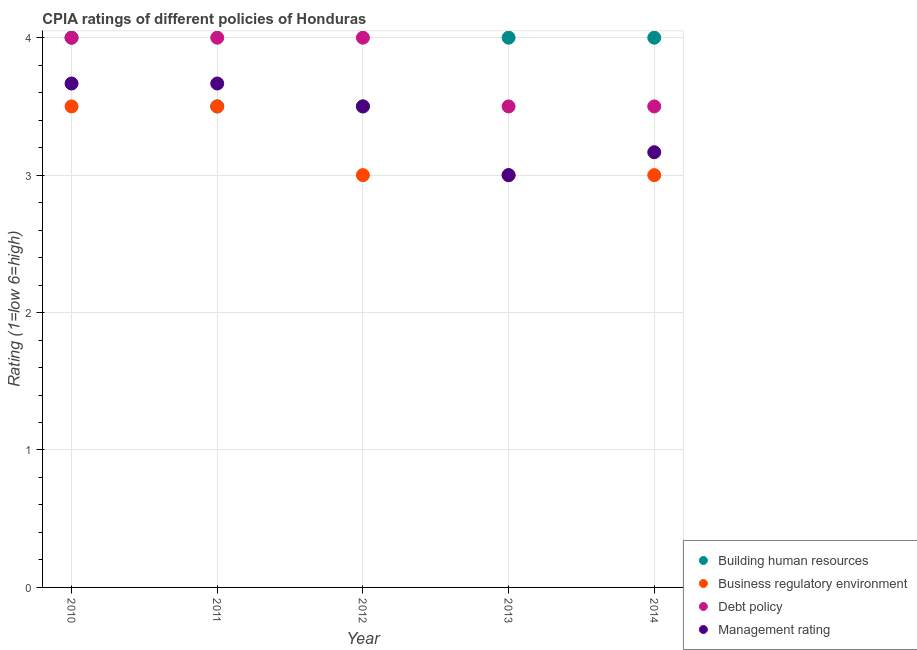Is the number of dotlines equal to the number of legend labels?
Give a very brief answer. Yes. What is the cpia rating of debt policy in 2013?
Your answer should be very brief. 3.5. Across all years, what is the maximum cpia rating of building human resources?
Provide a succinct answer. 4. In which year was the cpia rating of management maximum?
Offer a very short reply. 2010. What is the difference between the cpia rating of management in 2010 and the cpia rating of business regulatory environment in 2014?
Make the answer very short. 0.67. In the year 2011, what is the difference between the cpia rating of management and cpia rating of business regulatory environment?
Your answer should be very brief. 0.17. What is the ratio of the cpia rating of business regulatory environment in 2011 to that in 2012?
Make the answer very short. 1.17. Is the sum of the cpia rating of business regulatory environment in 2011 and 2014 greater than the maximum cpia rating of management across all years?
Give a very brief answer. Yes. Is it the case that in every year, the sum of the cpia rating of debt policy and cpia rating of business regulatory environment is greater than the sum of cpia rating of building human resources and cpia rating of management?
Offer a terse response. No. Is it the case that in every year, the sum of the cpia rating of building human resources and cpia rating of business regulatory environment is greater than the cpia rating of debt policy?
Offer a terse response. Yes. Is the cpia rating of debt policy strictly greater than the cpia rating of building human resources over the years?
Provide a succinct answer. No. Is the cpia rating of business regulatory environment strictly less than the cpia rating of building human resources over the years?
Make the answer very short. No. How many dotlines are there?
Ensure brevity in your answer.  4. How many years are there in the graph?
Make the answer very short. 5. What is the difference between two consecutive major ticks on the Y-axis?
Your answer should be compact. 1. Are the values on the major ticks of Y-axis written in scientific E-notation?
Give a very brief answer. No. Does the graph contain any zero values?
Offer a very short reply. No. Does the graph contain grids?
Your answer should be very brief. Yes. How many legend labels are there?
Make the answer very short. 4. What is the title of the graph?
Your response must be concise. CPIA ratings of different policies of Honduras. Does "Arable land" appear as one of the legend labels in the graph?
Your answer should be very brief. No. What is the label or title of the X-axis?
Your answer should be very brief. Year. What is the label or title of the Y-axis?
Make the answer very short. Rating (1=low 6=high). What is the Rating (1=low 6=high) in Business regulatory environment in 2010?
Your answer should be compact. 3.5. What is the Rating (1=low 6=high) in Management rating in 2010?
Your answer should be compact. 3.67. What is the Rating (1=low 6=high) of Building human resources in 2011?
Offer a terse response. 3.5. What is the Rating (1=low 6=high) of Business regulatory environment in 2011?
Your answer should be compact. 3.5. What is the Rating (1=low 6=high) in Debt policy in 2011?
Your response must be concise. 4. What is the Rating (1=low 6=high) of Management rating in 2011?
Provide a short and direct response. 3.67. What is the Rating (1=low 6=high) of Building human resources in 2012?
Your answer should be compact. 3.5. What is the Rating (1=low 6=high) in Debt policy in 2012?
Make the answer very short. 4. What is the Rating (1=low 6=high) in Management rating in 2012?
Give a very brief answer. 3.5. What is the Rating (1=low 6=high) of Debt policy in 2013?
Offer a terse response. 3.5. What is the Rating (1=low 6=high) of Management rating in 2013?
Ensure brevity in your answer.  3. What is the Rating (1=low 6=high) in Building human resources in 2014?
Your response must be concise. 4. What is the Rating (1=low 6=high) of Business regulatory environment in 2014?
Provide a short and direct response. 3. What is the Rating (1=low 6=high) in Debt policy in 2014?
Provide a succinct answer. 3.5. What is the Rating (1=low 6=high) of Management rating in 2014?
Keep it short and to the point. 3.17. Across all years, what is the maximum Rating (1=low 6=high) of Business regulatory environment?
Provide a short and direct response. 3.5. Across all years, what is the maximum Rating (1=low 6=high) in Debt policy?
Offer a terse response. 4. Across all years, what is the maximum Rating (1=low 6=high) in Management rating?
Make the answer very short. 3.67. Across all years, what is the minimum Rating (1=low 6=high) of Building human resources?
Provide a succinct answer. 3.5. Across all years, what is the minimum Rating (1=low 6=high) in Business regulatory environment?
Offer a very short reply. 3. Across all years, what is the minimum Rating (1=low 6=high) in Management rating?
Your answer should be compact. 3. What is the total Rating (1=low 6=high) of Debt policy in the graph?
Give a very brief answer. 19. What is the difference between the Rating (1=low 6=high) of Business regulatory environment in 2010 and that in 2011?
Ensure brevity in your answer.  0. What is the difference between the Rating (1=low 6=high) of Building human resources in 2010 and that in 2012?
Your answer should be compact. 0.5. What is the difference between the Rating (1=low 6=high) of Business regulatory environment in 2010 and that in 2012?
Your answer should be very brief. 0.5. What is the difference between the Rating (1=low 6=high) of Debt policy in 2010 and that in 2012?
Give a very brief answer. 0. What is the difference between the Rating (1=low 6=high) in Management rating in 2010 and that in 2012?
Give a very brief answer. 0.17. What is the difference between the Rating (1=low 6=high) in Building human resources in 2010 and that in 2013?
Your response must be concise. 0. What is the difference between the Rating (1=low 6=high) of Debt policy in 2010 and that in 2013?
Offer a terse response. 0.5. What is the difference between the Rating (1=low 6=high) in Building human resources in 2010 and that in 2014?
Make the answer very short. 0. What is the difference between the Rating (1=low 6=high) of Business regulatory environment in 2010 and that in 2014?
Ensure brevity in your answer.  0.5. What is the difference between the Rating (1=low 6=high) of Building human resources in 2011 and that in 2012?
Make the answer very short. 0. What is the difference between the Rating (1=low 6=high) of Business regulatory environment in 2011 and that in 2013?
Make the answer very short. 0.5. What is the difference between the Rating (1=low 6=high) of Debt policy in 2011 and that in 2013?
Your answer should be compact. 0.5. What is the difference between the Rating (1=low 6=high) in Business regulatory environment in 2011 and that in 2014?
Provide a short and direct response. 0.5. What is the difference between the Rating (1=low 6=high) of Debt policy in 2011 and that in 2014?
Your answer should be very brief. 0.5. What is the difference between the Rating (1=low 6=high) in Management rating in 2011 and that in 2014?
Give a very brief answer. 0.5. What is the difference between the Rating (1=low 6=high) of Building human resources in 2012 and that in 2013?
Your response must be concise. -0.5. What is the difference between the Rating (1=low 6=high) of Business regulatory environment in 2012 and that in 2013?
Offer a terse response. 0. What is the difference between the Rating (1=low 6=high) in Management rating in 2012 and that in 2013?
Provide a succinct answer. 0.5. What is the difference between the Rating (1=low 6=high) of Building human resources in 2012 and that in 2014?
Make the answer very short. -0.5. What is the difference between the Rating (1=low 6=high) in Business regulatory environment in 2013 and that in 2014?
Offer a very short reply. 0. What is the difference between the Rating (1=low 6=high) of Management rating in 2013 and that in 2014?
Your answer should be compact. -0.17. What is the difference between the Rating (1=low 6=high) in Building human resources in 2010 and the Rating (1=low 6=high) in Business regulatory environment in 2012?
Provide a short and direct response. 1. What is the difference between the Rating (1=low 6=high) of Building human resources in 2010 and the Rating (1=low 6=high) of Debt policy in 2012?
Keep it short and to the point. 0. What is the difference between the Rating (1=low 6=high) of Building human resources in 2010 and the Rating (1=low 6=high) of Management rating in 2012?
Offer a terse response. 0.5. What is the difference between the Rating (1=low 6=high) of Business regulatory environment in 2010 and the Rating (1=low 6=high) of Debt policy in 2012?
Your response must be concise. -0.5. What is the difference between the Rating (1=low 6=high) in Building human resources in 2010 and the Rating (1=low 6=high) in Business regulatory environment in 2013?
Keep it short and to the point. 1. What is the difference between the Rating (1=low 6=high) of Business regulatory environment in 2010 and the Rating (1=low 6=high) of Management rating in 2013?
Provide a succinct answer. 0.5. What is the difference between the Rating (1=low 6=high) in Debt policy in 2010 and the Rating (1=low 6=high) in Management rating in 2013?
Make the answer very short. 1. What is the difference between the Rating (1=low 6=high) of Building human resources in 2010 and the Rating (1=low 6=high) of Business regulatory environment in 2014?
Ensure brevity in your answer.  1. What is the difference between the Rating (1=low 6=high) of Building human resources in 2010 and the Rating (1=low 6=high) of Management rating in 2014?
Keep it short and to the point. 0.83. What is the difference between the Rating (1=low 6=high) in Building human resources in 2011 and the Rating (1=low 6=high) in Business regulatory environment in 2012?
Provide a succinct answer. 0.5. What is the difference between the Rating (1=low 6=high) of Building human resources in 2011 and the Rating (1=low 6=high) of Management rating in 2012?
Keep it short and to the point. 0. What is the difference between the Rating (1=low 6=high) in Business regulatory environment in 2011 and the Rating (1=low 6=high) in Management rating in 2012?
Offer a very short reply. 0. What is the difference between the Rating (1=low 6=high) of Building human resources in 2011 and the Rating (1=low 6=high) of Business regulatory environment in 2013?
Provide a short and direct response. 0.5. What is the difference between the Rating (1=low 6=high) of Building human resources in 2011 and the Rating (1=low 6=high) of Debt policy in 2013?
Your answer should be very brief. 0. What is the difference between the Rating (1=low 6=high) of Business regulatory environment in 2011 and the Rating (1=low 6=high) of Management rating in 2013?
Your response must be concise. 0.5. What is the difference between the Rating (1=low 6=high) of Business regulatory environment in 2011 and the Rating (1=low 6=high) of Debt policy in 2014?
Offer a very short reply. 0. What is the difference between the Rating (1=low 6=high) of Business regulatory environment in 2011 and the Rating (1=low 6=high) of Management rating in 2014?
Ensure brevity in your answer.  0.33. What is the difference between the Rating (1=low 6=high) in Building human resources in 2012 and the Rating (1=low 6=high) in Business regulatory environment in 2013?
Provide a short and direct response. 0.5. What is the difference between the Rating (1=low 6=high) in Building human resources in 2012 and the Rating (1=low 6=high) in Debt policy in 2013?
Your answer should be very brief. 0. What is the difference between the Rating (1=low 6=high) in Building human resources in 2012 and the Rating (1=low 6=high) in Management rating in 2013?
Keep it short and to the point. 0.5. What is the difference between the Rating (1=low 6=high) in Business regulatory environment in 2012 and the Rating (1=low 6=high) in Management rating in 2013?
Your answer should be compact. 0. What is the difference between the Rating (1=low 6=high) in Debt policy in 2012 and the Rating (1=low 6=high) in Management rating in 2013?
Offer a very short reply. 1. What is the difference between the Rating (1=low 6=high) of Building human resources in 2012 and the Rating (1=low 6=high) of Business regulatory environment in 2014?
Make the answer very short. 0.5. What is the difference between the Rating (1=low 6=high) of Building human resources in 2012 and the Rating (1=low 6=high) of Management rating in 2014?
Keep it short and to the point. 0.33. What is the difference between the Rating (1=low 6=high) in Business regulatory environment in 2012 and the Rating (1=low 6=high) in Debt policy in 2014?
Keep it short and to the point. -0.5. What is the difference between the Rating (1=low 6=high) in Debt policy in 2012 and the Rating (1=low 6=high) in Management rating in 2014?
Provide a succinct answer. 0.83. What is the difference between the Rating (1=low 6=high) in Building human resources in 2013 and the Rating (1=low 6=high) in Debt policy in 2014?
Provide a succinct answer. 0.5. What is the difference between the Rating (1=low 6=high) of Building human resources in 2013 and the Rating (1=low 6=high) of Management rating in 2014?
Give a very brief answer. 0.83. What is the difference between the Rating (1=low 6=high) of Business regulatory environment in 2013 and the Rating (1=low 6=high) of Management rating in 2014?
Offer a terse response. -0.17. What is the average Rating (1=low 6=high) of Building human resources per year?
Your answer should be compact. 3.8. What is the average Rating (1=low 6=high) of Business regulatory environment per year?
Provide a succinct answer. 3.2. In the year 2010, what is the difference between the Rating (1=low 6=high) of Building human resources and Rating (1=low 6=high) of Business regulatory environment?
Offer a terse response. 0.5. In the year 2010, what is the difference between the Rating (1=low 6=high) in Building human resources and Rating (1=low 6=high) in Debt policy?
Give a very brief answer. 0. In the year 2010, what is the difference between the Rating (1=low 6=high) in Business regulatory environment and Rating (1=low 6=high) in Debt policy?
Your answer should be very brief. -0.5. In the year 2010, what is the difference between the Rating (1=low 6=high) in Debt policy and Rating (1=low 6=high) in Management rating?
Offer a very short reply. 0.33. In the year 2011, what is the difference between the Rating (1=low 6=high) of Building human resources and Rating (1=low 6=high) of Debt policy?
Keep it short and to the point. -0.5. In the year 2012, what is the difference between the Rating (1=low 6=high) of Building human resources and Rating (1=low 6=high) of Debt policy?
Give a very brief answer. -0.5. In the year 2012, what is the difference between the Rating (1=low 6=high) of Building human resources and Rating (1=low 6=high) of Management rating?
Offer a very short reply. 0. In the year 2012, what is the difference between the Rating (1=low 6=high) in Business regulatory environment and Rating (1=low 6=high) in Debt policy?
Give a very brief answer. -1. In the year 2013, what is the difference between the Rating (1=low 6=high) in Building human resources and Rating (1=low 6=high) in Business regulatory environment?
Keep it short and to the point. 1. In the year 2013, what is the difference between the Rating (1=low 6=high) of Building human resources and Rating (1=low 6=high) of Debt policy?
Offer a very short reply. 0.5. In the year 2013, what is the difference between the Rating (1=low 6=high) in Debt policy and Rating (1=low 6=high) in Management rating?
Provide a succinct answer. 0.5. In the year 2014, what is the difference between the Rating (1=low 6=high) in Business regulatory environment and Rating (1=low 6=high) in Management rating?
Keep it short and to the point. -0.17. What is the ratio of the Rating (1=low 6=high) of Business regulatory environment in 2010 to that in 2011?
Provide a short and direct response. 1. What is the ratio of the Rating (1=low 6=high) in Debt policy in 2010 to that in 2011?
Offer a terse response. 1. What is the ratio of the Rating (1=low 6=high) of Business regulatory environment in 2010 to that in 2012?
Keep it short and to the point. 1.17. What is the ratio of the Rating (1=low 6=high) in Management rating in 2010 to that in 2012?
Offer a very short reply. 1.05. What is the ratio of the Rating (1=low 6=high) of Business regulatory environment in 2010 to that in 2013?
Your response must be concise. 1.17. What is the ratio of the Rating (1=low 6=high) of Management rating in 2010 to that in 2013?
Your answer should be very brief. 1.22. What is the ratio of the Rating (1=low 6=high) of Debt policy in 2010 to that in 2014?
Offer a terse response. 1.14. What is the ratio of the Rating (1=low 6=high) of Management rating in 2010 to that in 2014?
Offer a terse response. 1.16. What is the ratio of the Rating (1=low 6=high) in Building human resources in 2011 to that in 2012?
Provide a short and direct response. 1. What is the ratio of the Rating (1=low 6=high) of Business regulatory environment in 2011 to that in 2012?
Provide a short and direct response. 1.17. What is the ratio of the Rating (1=low 6=high) of Management rating in 2011 to that in 2012?
Your answer should be compact. 1.05. What is the ratio of the Rating (1=low 6=high) in Business regulatory environment in 2011 to that in 2013?
Your answer should be very brief. 1.17. What is the ratio of the Rating (1=low 6=high) in Debt policy in 2011 to that in 2013?
Ensure brevity in your answer.  1.14. What is the ratio of the Rating (1=low 6=high) of Management rating in 2011 to that in 2013?
Provide a short and direct response. 1.22. What is the ratio of the Rating (1=low 6=high) in Management rating in 2011 to that in 2014?
Your answer should be compact. 1.16. What is the ratio of the Rating (1=low 6=high) in Building human resources in 2012 to that in 2013?
Your answer should be compact. 0.88. What is the ratio of the Rating (1=low 6=high) in Debt policy in 2012 to that in 2013?
Offer a terse response. 1.14. What is the ratio of the Rating (1=low 6=high) in Building human resources in 2012 to that in 2014?
Offer a terse response. 0.88. What is the ratio of the Rating (1=low 6=high) in Business regulatory environment in 2012 to that in 2014?
Keep it short and to the point. 1. What is the ratio of the Rating (1=low 6=high) in Debt policy in 2012 to that in 2014?
Your answer should be very brief. 1.14. What is the ratio of the Rating (1=low 6=high) in Management rating in 2012 to that in 2014?
Your response must be concise. 1.11. What is the ratio of the Rating (1=low 6=high) in Business regulatory environment in 2013 to that in 2014?
Make the answer very short. 1. What is the ratio of the Rating (1=low 6=high) of Debt policy in 2013 to that in 2014?
Make the answer very short. 1. What is the ratio of the Rating (1=low 6=high) of Management rating in 2013 to that in 2014?
Offer a very short reply. 0.95. What is the difference between the highest and the second highest Rating (1=low 6=high) of Building human resources?
Ensure brevity in your answer.  0. What is the difference between the highest and the second highest Rating (1=low 6=high) of Business regulatory environment?
Offer a terse response. 0. What is the difference between the highest and the second highest Rating (1=low 6=high) in Debt policy?
Provide a short and direct response. 0. What is the difference between the highest and the second highest Rating (1=low 6=high) of Management rating?
Provide a short and direct response. 0. What is the difference between the highest and the lowest Rating (1=low 6=high) in Building human resources?
Your response must be concise. 0.5. What is the difference between the highest and the lowest Rating (1=low 6=high) of Debt policy?
Provide a short and direct response. 0.5. 